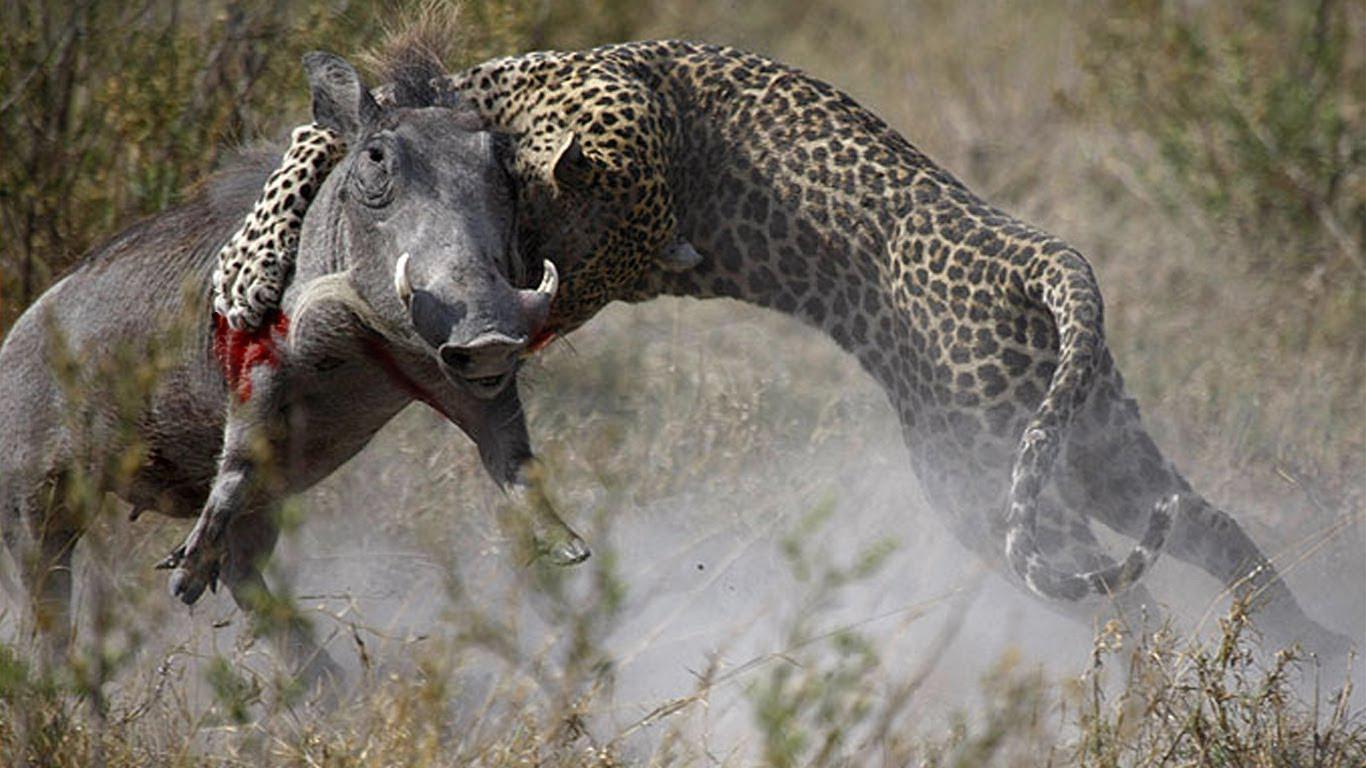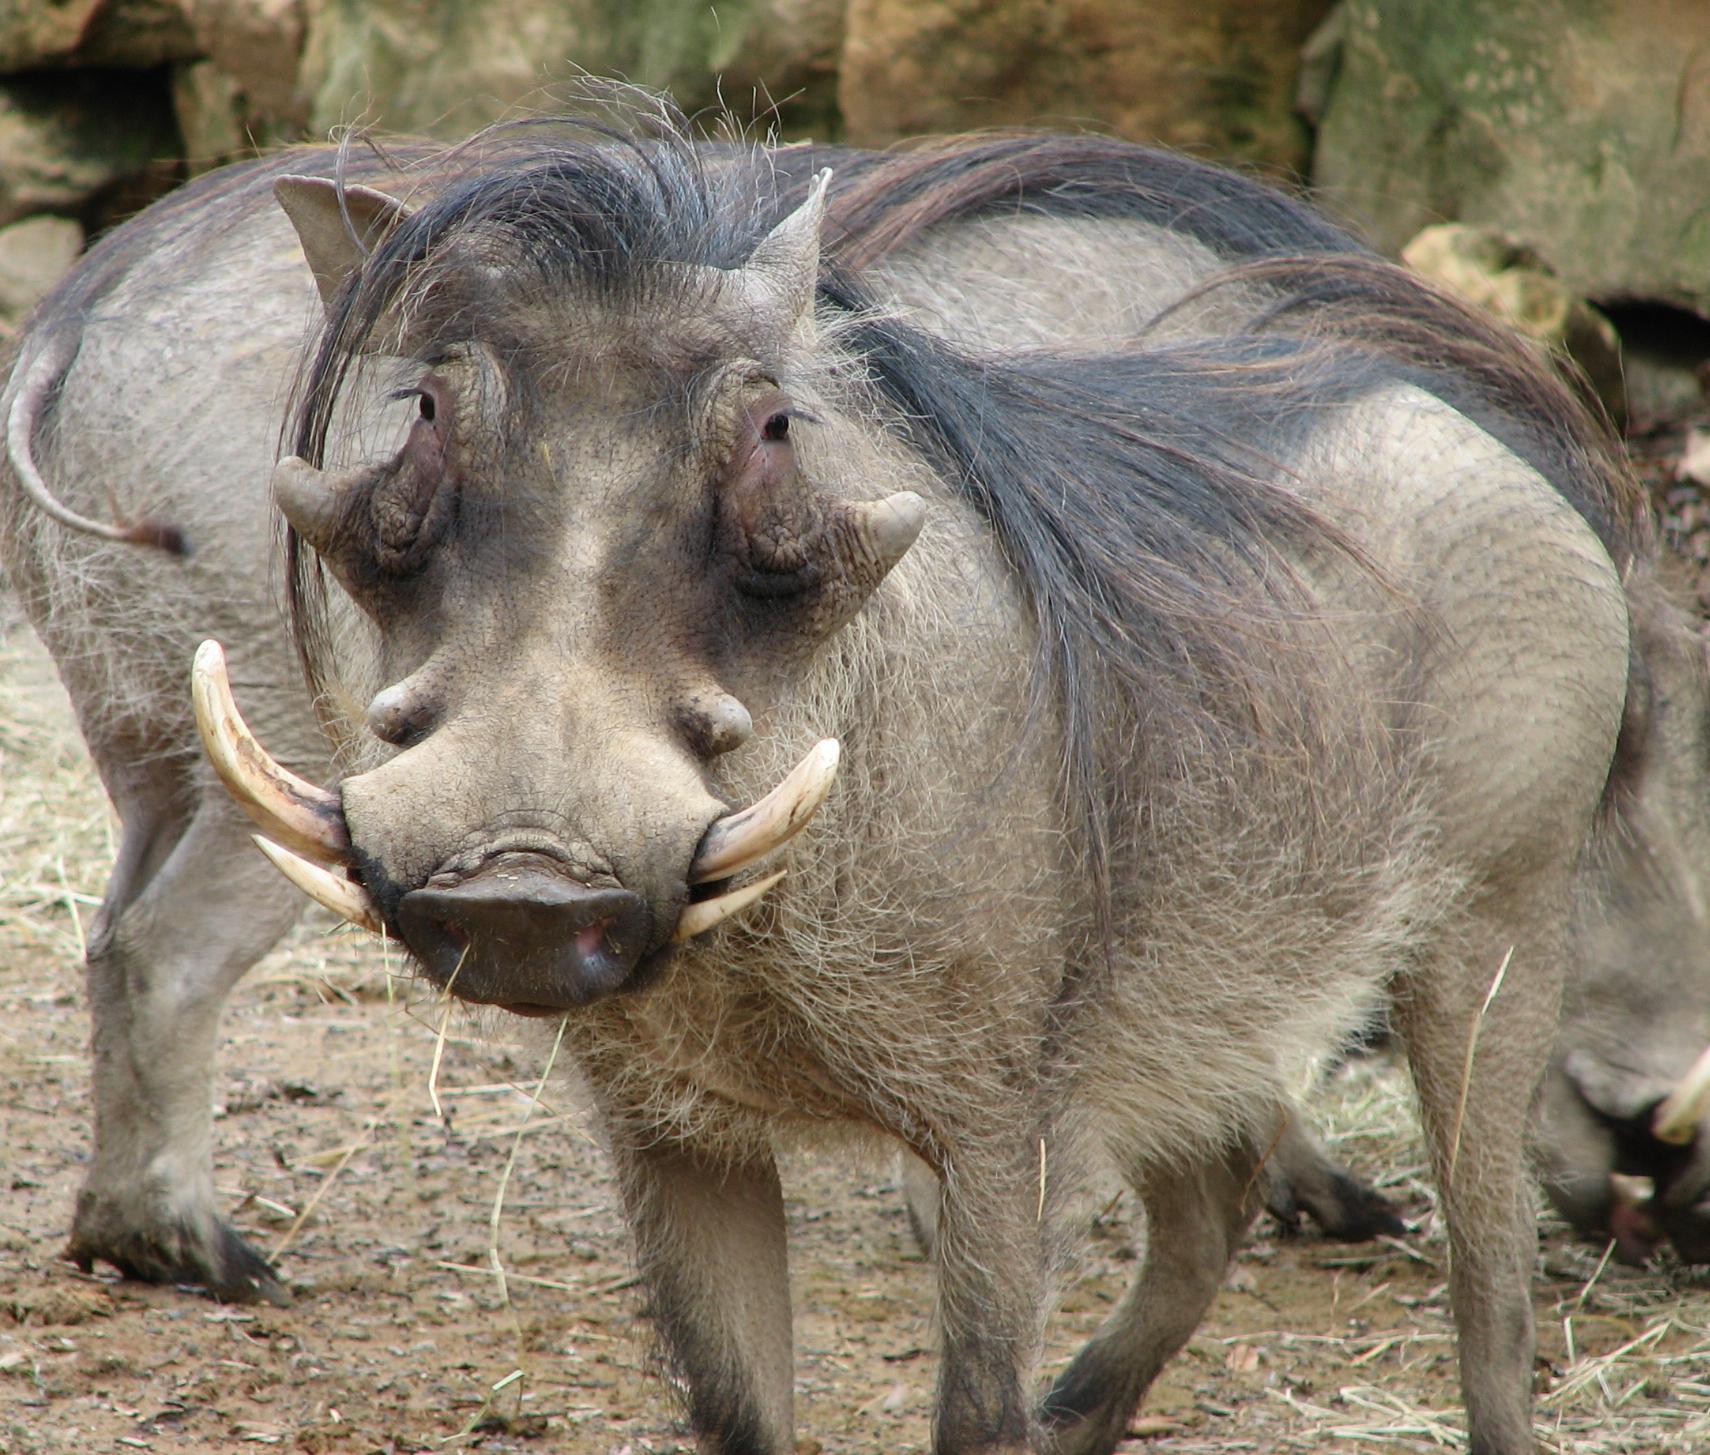The first image is the image on the left, the second image is the image on the right. Considering the images on both sides, is "The image on the left contains exactly two animals." valid? Answer yes or no. Yes. 